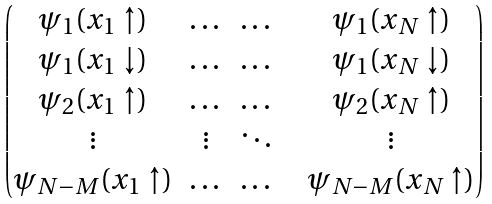<formula> <loc_0><loc_0><loc_500><loc_500>\begin{pmatrix} \psi _ { 1 } ( x _ { 1 } \uparrow ) & \dots & \dots & & \psi _ { 1 } ( x _ { N } \uparrow ) \\ \psi _ { 1 } ( x _ { 1 } \downarrow ) & \dots & \dots & & \psi _ { 1 } ( x _ { N } \downarrow ) \\ \psi _ { 2 } ( x _ { 1 } \uparrow ) & \dots & \dots & & \psi _ { 2 } ( x _ { N } \uparrow ) \\ \vdots & \vdots & \ddots & & \vdots \\ \psi _ { N - M } ( x _ { 1 } \uparrow ) & \dots & \dots & & \psi _ { N - M } ( x _ { N } \uparrow ) \end{pmatrix}</formula> 